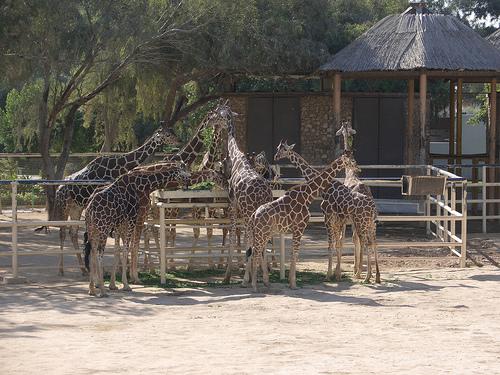What do cows give us to drink?
Quick response, please. Milk. What are the animals standing next to?
Concise answer only. Fence. Are these animals in the wild?
Give a very brief answer. No. Are they looking at the giraffes?
Write a very short answer. Yes. Are there any giraffes under the pavilion?
Keep it brief. No. Are the giraffes eating?
Be succinct. Yes. What animal is pictured?
Answer briefly. Giraffe. Would this be a romantic getaway?
Answer briefly. No. 